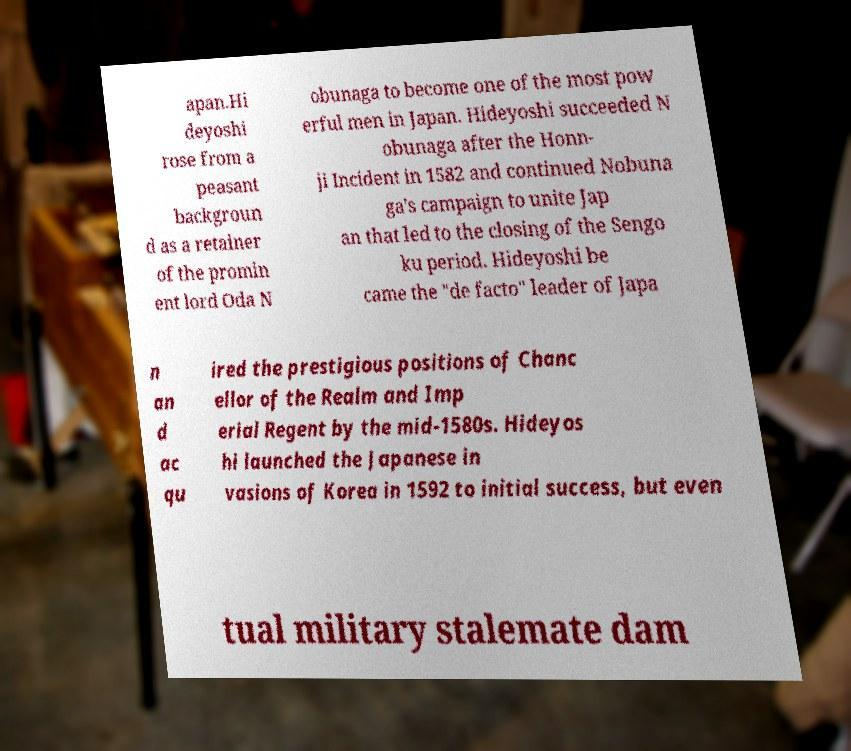I need the written content from this picture converted into text. Can you do that? apan.Hi deyoshi rose from a peasant backgroun d as a retainer of the promin ent lord Oda N obunaga to become one of the most pow erful men in Japan. Hideyoshi succeeded N obunaga after the Honn- ji Incident in 1582 and continued Nobuna ga's campaign to unite Jap an that led to the closing of the Sengo ku period. Hideyoshi be came the "de facto" leader of Japa n an d ac qu ired the prestigious positions of Chanc ellor of the Realm and Imp erial Regent by the mid-1580s. Hideyos hi launched the Japanese in vasions of Korea in 1592 to initial success, but even tual military stalemate dam 